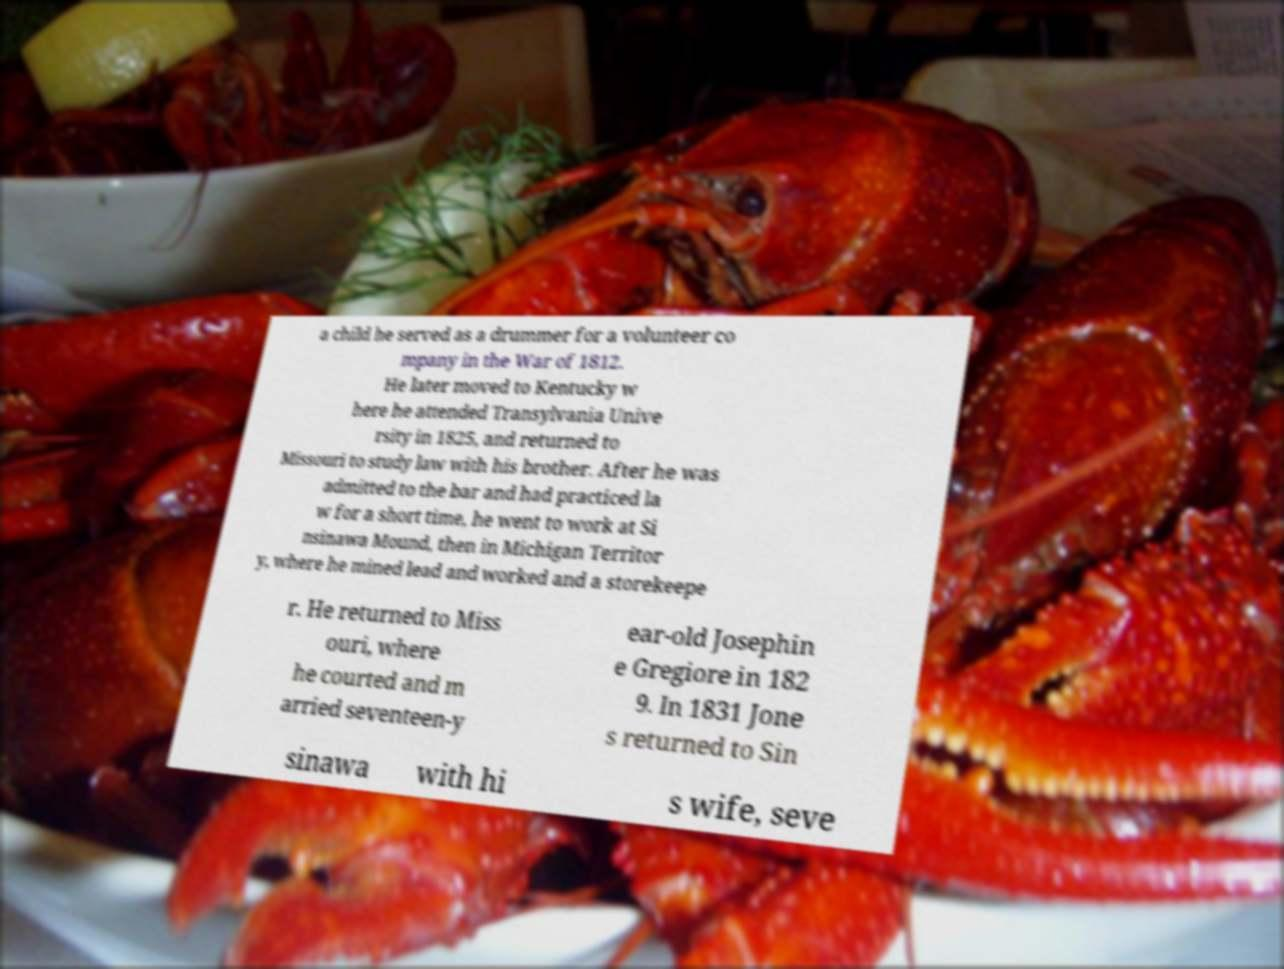I need the written content from this picture converted into text. Can you do that? a child he served as a drummer for a volunteer co mpany in the War of 1812. He later moved to Kentucky w here he attended Transylvania Unive rsity in 1825, and returned to Missouri to study law with his brother. After he was admitted to the bar and had practiced la w for a short time, he went to work at Si nsinawa Mound, then in Michigan Territor y, where he mined lead and worked and a storekeepe r. He returned to Miss ouri, where he courted and m arried seventeen-y ear-old Josephin e Gregiore in 182 9. In 1831 Jone s returned to Sin sinawa with hi s wife, seve 